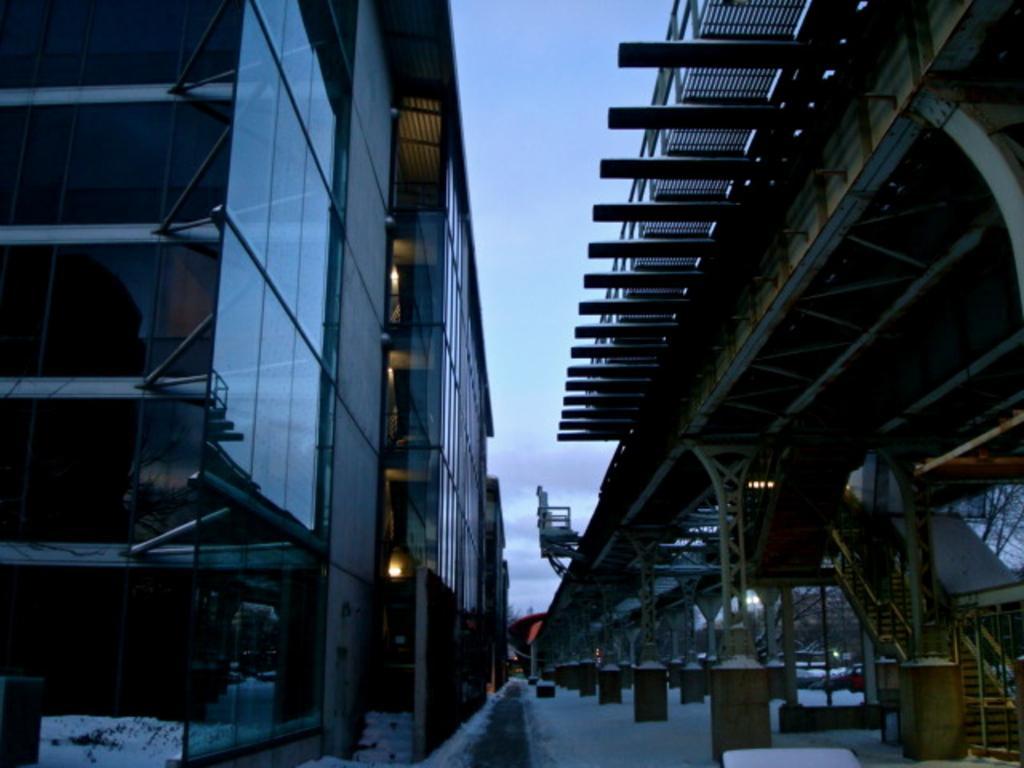Please provide a concise description of this image. In this image we can see buildings, staircase, railings, snow on the road and sky with clouds. 